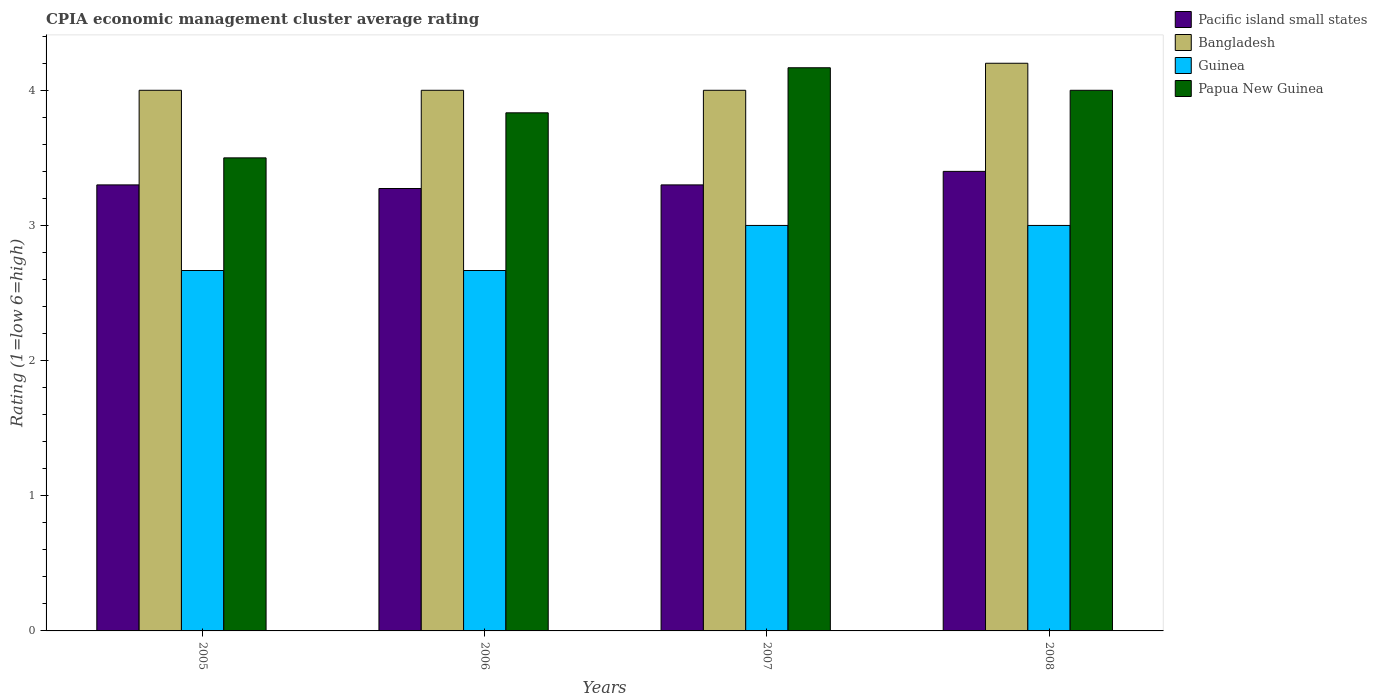How many groups of bars are there?
Give a very brief answer. 4. Are the number of bars per tick equal to the number of legend labels?
Provide a succinct answer. Yes. Are the number of bars on each tick of the X-axis equal?
Keep it short and to the point. Yes. How many bars are there on the 1st tick from the right?
Your answer should be compact. 4. What is the label of the 1st group of bars from the left?
Your answer should be compact. 2005. In how many cases, is the number of bars for a given year not equal to the number of legend labels?
Your response must be concise. 0. What is the CPIA rating in Papua New Guinea in 2007?
Provide a succinct answer. 4.17. Across all years, what is the maximum CPIA rating in Bangladesh?
Offer a terse response. 4.2. Across all years, what is the minimum CPIA rating in Guinea?
Keep it short and to the point. 2.67. In which year was the CPIA rating in Guinea maximum?
Your answer should be compact. 2007. In which year was the CPIA rating in Pacific island small states minimum?
Your answer should be very brief. 2006. What is the total CPIA rating in Guinea in the graph?
Offer a very short reply. 11.33. What is the difference between the CPIA rating in Guinea in 2005 and that in 2007?
Offer a very short reply. -0.33. What is the difference between the CPIA rating in Bangladesh in 2007 and the CPIA rating in Guinea in 2005?
Your answer should be compact. 1.33. What is the average CPIA rating in Pacific island small states per year?
Provide a short and direct response. 3.32. In the year 2006, what is the difference between the CPIA rating in Papua New Guinea and CPIA rating in Guinea?
Your response must be concise. 1.17. What is the ratio of the CPIA rating in Papua New Guinea in 2005 to that in 2007?
Your answer should be very brief. 0.84. Is the CPIA rating in Bangladesh in 2005 less than that in 2006?
Offer a very short reply. No. What is the difference between the highest and the second highest CPIA rating in Papua New Guinea?
Provide a succinct answer. 0.17. What is the difference between the highest and the lowest CPIA rating in Bangladesh?
Offer a terse response. 0.2. Is the sum of the CPIA rating in Bangladesh in 2005 and 2007 greater than the maximum CPIA rating in Guinea across all years?
Your answer should be very brief. Yes. Is it the case that in every year, the sum of the CPIA rating in Guinea and CPIA rating in Bangladesh is greater than the sum of CPIA rating in Pacific island small states and CPIA rating in Papua New Guinea?
Make the answer very short. Yes. What does the 4th bar from the left in 2005 represents?
Make the answer very short. Papua New Guinea. What does the 2nd bar from the right in 2006 represents?
Provide a short and direct response. Guinea. How many years are there in the graph?
Offer a terse response. 4. Does the graph contain grids?
Your response must be concise. No. How many legend labels are there?
Make the answer very short. 4. What is the title of the graph?
Keep it short and to the point. CPIA economic management cluster average rating. Does "Sub-Saharan Africa (all income levels)" appear as one of the legend labels in the graph?
Your response must be concise. No. What is the label or title of the X-axis?
Your answer should be compact. Years. What is the Rating (1=low 6=high) in Guinea in 2005?
Provide a short and direct response. 2.67. What is the Rating (1=low 6=high) in Pacific island small states in 2006?
Offer a terse response. 3.27. What is the Rating (1=low 6=high) in Bangladesh in 2006?
Your answer should be compact. 4. What is the Rating (1=low 6=high) of Guinea in 2006?
Offer a terse response. 2.67. What is the Rating (1=low 6=high) of Papua New Guinea in 2006?
Keep it short and to the point. 3.83. What is the Rating (1=low 6=high) in Papua New Guinea in 2007?
Make the answer very short. 4.17. What is the Rating (1=low 6=high) of Bangladesh in 2008?
Provide a succinct answer. 4.2. What is the Rating (1=low 6=high) in Guinea in 2008?
Provide a short and direct response. 3. What is the Rating (1=low 6=high) in Papua New Guinea in 2008?
Offer a terse response. 4. Across all years, what is the maximum Rating (1=low 6=high) of Pacific island small states?
Provide a short and direct response. 3.4. Across all years, what is the maximum Rating (1=low 6=high) in Guinea?
Offer a very short reply. 3. Across all years, what is the maximum Rating (1=low 6=high) in Papua New Guinea?
Your answer should be very brief. 4.17. Across all years, what is the minimum Rating (1=low 6=high) in Pacific island small states?
Your answer should be very brief. 3.27. Across all years, what is the minimum Rating (1=low 6=high) in Guinea?
Provide a short and direct response. 2.67. What is the total Rating (1=low 6=high) in Pacific island small states in the graph?
Offer a very short reply. 13.27. What is the total Rating (1=low 6=high) in Bangladesh in the graph?
Your response must be concise. 16.2. What is the total Rating (1=low 6=high) in Guinea in the graph?
Offer a terse response. 11.33. What is the difference between the Rating (1=low 6=high) of Pacific island small states in 2005 and that in 2006?
Offer a very short reply. 0.03. What is the difference between the Rating (1=low 6=high) of Guinea in 2005 and that in 2006?
Provide a succinct answer. 0. What is the difference between the Rating (1=low 6=high) of Papua New Guinea in 2005 and that in 2006?
Make the answer very short. -0.33. What is the difference between the Rating (1=low 6=high) of Guinea in 2005 and that in 2007?
Provide a short and direct response. -0.33. What is the difference between the Rating (1=low 6=high) of Papua New Guinea in 2005 and that in 2007?
Your response must be concise. -0.67. What is the difference between the Rating (1=low 6=high) of Bangladesh in 2005 and that in 2008?
Your answer should be compact. -0.2. What is the difference between the Rating (1=low 6=high) of Papua New Guinea in 2005 and that in 2008?
Keep it short and to the point. -0.5. What is the difference between the Rating (1=low 6=high) in Pacific island small states in 2006 and that in 2007?
Provide a succinct answer. -0.03. What is the difference between the Rating (1=low 6=high) in Pacific island small states in 2006 and that in 2008?
Offer a very short reply. -0.13. What is the difference between the Rating (1=low 6=high) in Bangladesh in 2006 and that in 2008?
Offer a very short reply. -0.2. What is the difference between the Rating (1=low 6=high) in Guinea in 2006 and that in 2008?
Offer a terse response. -0.33. What is the difference between the Rating (1=low 6=high) in Papua New Guinea in 2006 and that in 2008?
Your answer should be compact. -0.17. What is the difference between the Rating (1=low 6=high) of Pacific island small states in 2007 and that in 2008?
Make the answer very short. -0.1. What is the difference between the Rating (1=low 6=high) in Pacific island small states in 2005 and the Rating (1=low 6=high) in Guinea in 2006?
Your answer should be very brief. 0.63. What is the difference between the Rating (1=low 6=high) of Pacific island small states in 2005 and the Rating (1=low 6=high) of Papua New Guinea in 2006?
Make the answer very short. -0.53. What is the difference between the Rating (1=low 6=high) of Bangladesh in 2005 and the Rating (1=low 6=high) of Guinea in 2006?
Your response must be concise. 1.33. What is the difference between the Rating (1=low 6=high) in Bangladesh in 2005 and the Rating (1=low 6=high) in Papua New Guinea in 2006?
Your answer should be compact. 0.17. What is the difference between the Rating (1=low 6=high) of Guinea in 2005 and the Rating (1=low 6=high) of Papua New Guinea in 2006?
Your answer should be very brief. -1.17. What is the difference between the Rating (1=low 6=high) of Pacific island small states in 2005 and the Rating (1=low 6=high) of Bangladesh in 2007?
Your response must be concise. -0.7. What is the difference between the Rating (1=low 6=high) of Pacific island small states in 2005 and the Rating (1=low 6=high) of Papua New Guinea in 2007?
Ensure brevity in your answer.  -0.87. What is the difference between the Rating (1=low 6=high) in Bangladesh in 2005 and the Rating (1=low 6=high) in Guinea in 2007?
Provide a short and direct response. 1. What is the difference between the Rating (1=low 6=high) in Bangladesh in 2005 and the Rating (1=low 6=high) in Papua New Guinea in 2007?
Provide a succinct answer. -0.17. What is the difference between the Rating (1=low 6=high) in Guinea in 2005 and the Rating (1=low 6=high) in Papua New Guinea in 2007?
Your answer should be very brief. -1.5. What is the difference between the Rating (1=low 6=high) in Pacific island small states in 2005 and the Rating (1=low 6=high) in Bangladesh in 2008?
Keep it short and to the point. -0.9. What is the difference between the Rating (1=low 6=high) of Pacific island small states in 2005 and the Rating (1=low 6=high) of Papua New Guinea in 2008?
Your answer should be compact. -0.7. What is the difference between the Rating (1=low 6=high) in Bangladesh in 2005 and the Rating (1=low 6=high) in Guinea in 2008?
Offer a very short reply. 1. What is the difference between the Rating (1=low 6=high) of Guinea in 2005 and the Rating (1=low 6=high) of Papua New Guinea in 2008?
Provide a succinct answer. -1.33. What is the difference between the Rating (1=low 6=high) of Pacific island small states in 2006 and the Rating (1=low 6=high) of Bangladesh in 2007?
Offer a terse response. -0.73. What is the difference between the Rating (1=low 6=high) in Pacific island small states in 2006 and the Rating (1=low 6=high) in Guinea in 2007?
Offer a very short reply. 0.27. What is the difference between the Rating (1=low 6=high) in Pacific island small states in 2006 and the Rating (1=low 6=high) in Papua New Guinea in 2007?
Make the answer very short. -0.89. What is the difference between the Rating (1=low 6=high) of Bangladesh in 2006 and the Rating (1=low 6=high) of Guinea in 2007?
Provide a succinct answer. 1. What is the difference between the Rating (1=low 6=high) in Pacific island small states in 2006 and the Rating (1=low 6=high) in Bangladesh in 2008?
Provide a short and direct response. -0.93. What is the difference between the Rating (1=low 6=high) of Pacific island small states in 2006 and the Rating (1=low 6=high) of Guinea in 2008?
Your answer should be very brief. 0.27. What is the difference between the Rating (1=low 6=high) of Pacific island small states in 2006 and the Rating (1=low 6=high) of Papua New Guinea in 2008?
Offer a very short reply. -0.73. What is the difference between the Rating (1=low 6=high) of Bangladesh in 2006 and the Rating (1=low 6=high) of Guinea in 2008?
Keep it short and to the point. 1. What is the difference between the Rating (1=low 6=high) of Guinea in 2006 and the Rating (1=low 6=high) of Papua New Guinea in 2008?
Provide a succinct answer. -1.33. What is the difference between the Rating (1=low 6=high) in Pacific island small states in 2007 and the Rating (1=low 6=high) in Guinea in 2008?
Provide a short and direct response. 0.3. What is the difference between the Rating (1=low 6=high) of Pacific island small states in 2007 and the Rating (1=low 6=high) of Papua New Guinea in 2008?
Your answer should be very brief. -0.7. What is the difference between the Rating (1=low 6=high) in Bangladesh in 2007 and the Rating (1=low 6=high) in Guinea in 2008?
Your response must be concise. 1. What is the difference between the Rating (1=low 6=high) in Bangladesh in 2007 and the Rating (1=low 6=high) in Papua New Guinea in 2008?
Keep it short and to the point. 0. What is the average Rating (1=low 6=high) in Pacific island small states per year?
Your answer should be compact. 3.32. What is the average Rating (1=low 6=high) in Bangladesh per year?
Provide a short and direct response. 4.05. What is the average Rating (1=low 6=high) in Guinea per year?
Offer a very short reply. 2.83. What is the average Rating (1=low 6=high) of Papua New Guinea per year?
Keep it short and to the point. 3.88. In the year 2005, what is the difference between the Rating (1=low 6=high) of Pacific island small states and Rating (1=low 6=high) of Guinea?
Provide a short and direct response. 0.63. In the year 2005, what is the difference between the Rating (1=low 6=high) of Pacific island small states and Rating (1=low 6=high) of Papua New Guinea?
Your response must be concise. -0.2. In the year 2006, what is the difference between the Rating (1=low 6=high) of Pacific island small states and Rating (1=low 6=high) of Bangladesh?
Offer a terse response. -0.73. In the year 2006, what is the difference between the Rating (1=low 6=high) in Pacific island small states and Rating (1=low 6=high) in Guinea?
Your answer should be very brief. 0.61. In the year 2006, what is the difference between the Rating (1=low 6=high) in Pacific island small states and Rating (1=low 6=high) in Papua New Guinea?
Keep it short and to the point. -0.56. In the year 2006, what is the difference between the Rating (1=low 6=high) of Bangladesh and Rating (1=low 6=high) of Guinea?
Ensure brevity in your answer.  1.33. In the year 2006, what is the difference between the Rating (1=low 6=high) in Bangladesh and Rating (1=low 6=high) in Papua New Guinea?
Keep it short and to the point. 0.17. In the year 2006, what is the difference between the Rating (1=low 6=high) of Guinea and Rating (1=low 6=high) of Papua New Guinea?
Keep it short and to the point. -1.17. In the year 2007, what is the difference between the Rating (1=low 6=high) of Pacific island small states and Rating (1=low 6=high) of Guinea?
Give a very brief answer. 0.3. In the year 2007, what is the difference between the Rating (1=low 6=high) of Pacific island small states and Rating (1=low 6=high) of Papua New Guinea?
Provide a short and direct response. -0.87. In the year 2007, what is the difference between the Rating (1=low 6=high) of Bangladesh and Rating (1=low 6=high) of Guinea?
Make the answer very short. 1. In the year 2007, what is the difference between the Rating (1=low 6=high) of Bangladesh and Rating (1=low 6=high) of Papua New Guinea?
Make the answer very short. -0.17. In the year 2007, what is the difference between the Rating (1=low 6=high) in Guinea and Rating (1=low 6=high) in Papua New Guinea?
Your answer should be compact. -1.17. In the year 2008, what is the difference between the Rating (1=low 6=high) of Pacific island small states and Rating (1=low 6=high) of Guinea?
Your answer should be compact. 0.4. What is the ratio of the Rating (1=low 6=high) in Papua New Guinea in 2005 to that in 2006?
Ensure brevity in your answer.  0.91. What is the ratio of the Rating (1=low 6=high) in Pacific island small states in 2005 to that in 2007?
Offer a terse response. 1. What is the ratio of the Rating (1=low 6=high) in Bangladesh in 2005 to that in 2007?
Ensure brevity in your answer.  1. What is the ratio of the Rating (1=low 6=high) in Guinea in 2005 to that in 2007?
Offer a very short reply. 0.89. What is the ratio of the Rating (1=low 6=high) in Papua New Guinea in 2005 to that in 2007?
Offer a terse response. 0.84. What is the ratio of the Rating (1=low 6=high) of Pacific island small states in 2005 to that in 2008?
Provide a succinct answer. 0.97. What is the ratio of the Rating (1=low 6=high) in Bangladesh in 2005 to that in 2008?
Make the answer very short. 0.95. What is the ratio of the Rating (1=low 6=high) in Papua New Guinea in 2005 to that in 2008?
Offer a terse response. 0.88. What is the ratio of the Rating (1=low 6=high) in Bangladesh in 2006 to that in 2007?
Your response must be concise. 1. What is the ratio of the Rating (1=low 6=high) in Guinea in 2006 to that in 2007?
Your response must be concise. 0.89. What is the ratio of the Rating (1=low 6=high) of Pacific island small states in 2006 to that in 2008?
Provide a succinct answer. 0.96. What is the ratio of the Rating (1=low 6=high) in Papua New Guinea in 2006 to that in 2008?
Provide a succinct answer. 0.96. What is the ratio of the Rating (1=low 6=high) of Pacific island small states in 2007 to that in 2008?
Offer a very short reply. 0.97. What is the ratio of the Rating (1=low 6=high) of Bangladesh in 2007 to that in 2008?
Offer a very short reply. 0.95. What is the ratio of the Rating (1=low 6=high) in Guinea in 2007 to that in 2008?
Provide a succinct answer. 1. What is the ratio of the Rating (1=low 6=high) in Papua New Guinea in 2007 to that in 2008?
Ensure brevity in your answer.  1.04. What is the difference between the highest and the second highest Rating (1=low 6=high) in Pacific island small states?
Your answer should be very brief. 0.1. What is the difference between the highest and the second highest Rating (1=low 6=high) of Bangladesh?
Give a very brief answer. 0.2. What is the difference between the highest and the second highest Rating (1=low 6=high) of Guinea?
Your answer should be very brief. 0. What is the difference between the highest and the second highest Rating (1=low 6=high) of Papua New Guinea?
Offer a very short reply. 0.17. What is the difference between the highest and the lowest Rating (1=low 6=high) of Pacific island small states?
Provide a short and direct response. 0.13. What is the difference between the highest and the lowest Rating (1=low 6=high) of Bangladesh?
Provide a short and direct response. 0.2. What is the difference between the highest and the lowest Rating (1=low 6=high) of Guinea?
Your answer should be very brief. 0.33. 